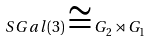<formula> <loc_0><loc_0><loc_500><loc_500>S G a l ( 3 ) \cong G _ { 2 } \rtimes G _ { 1 }</formula> 